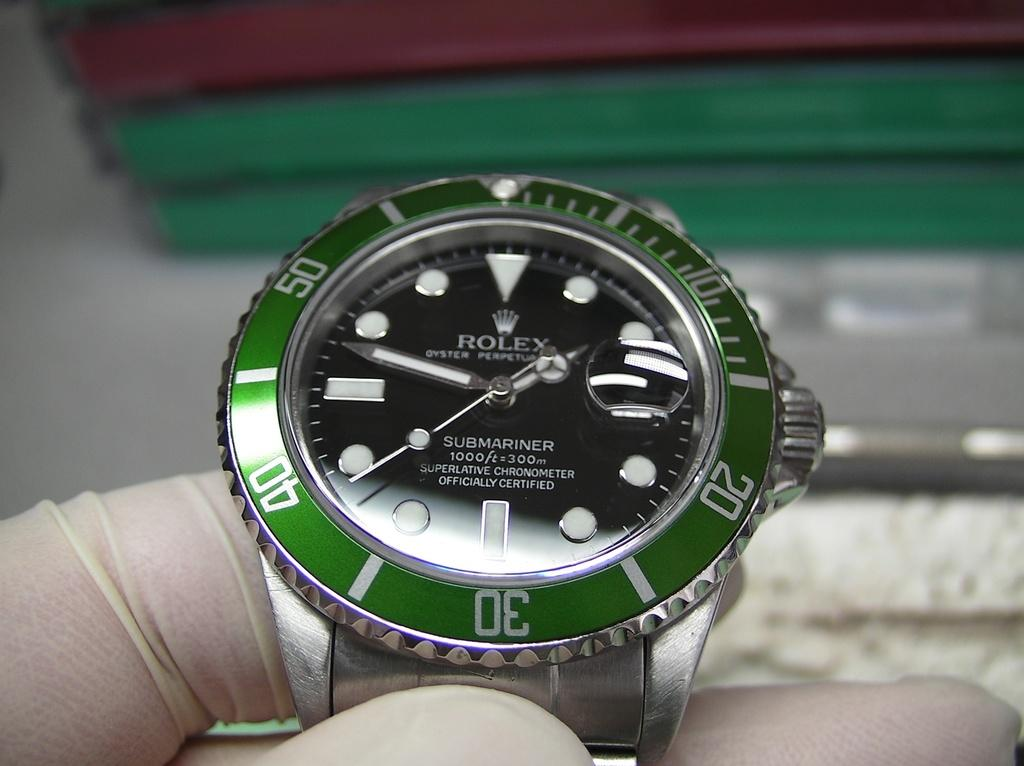<image>
Summarize the visual content of the image. someone with gloves is holding a green Rolex watch that reads 1:48. 